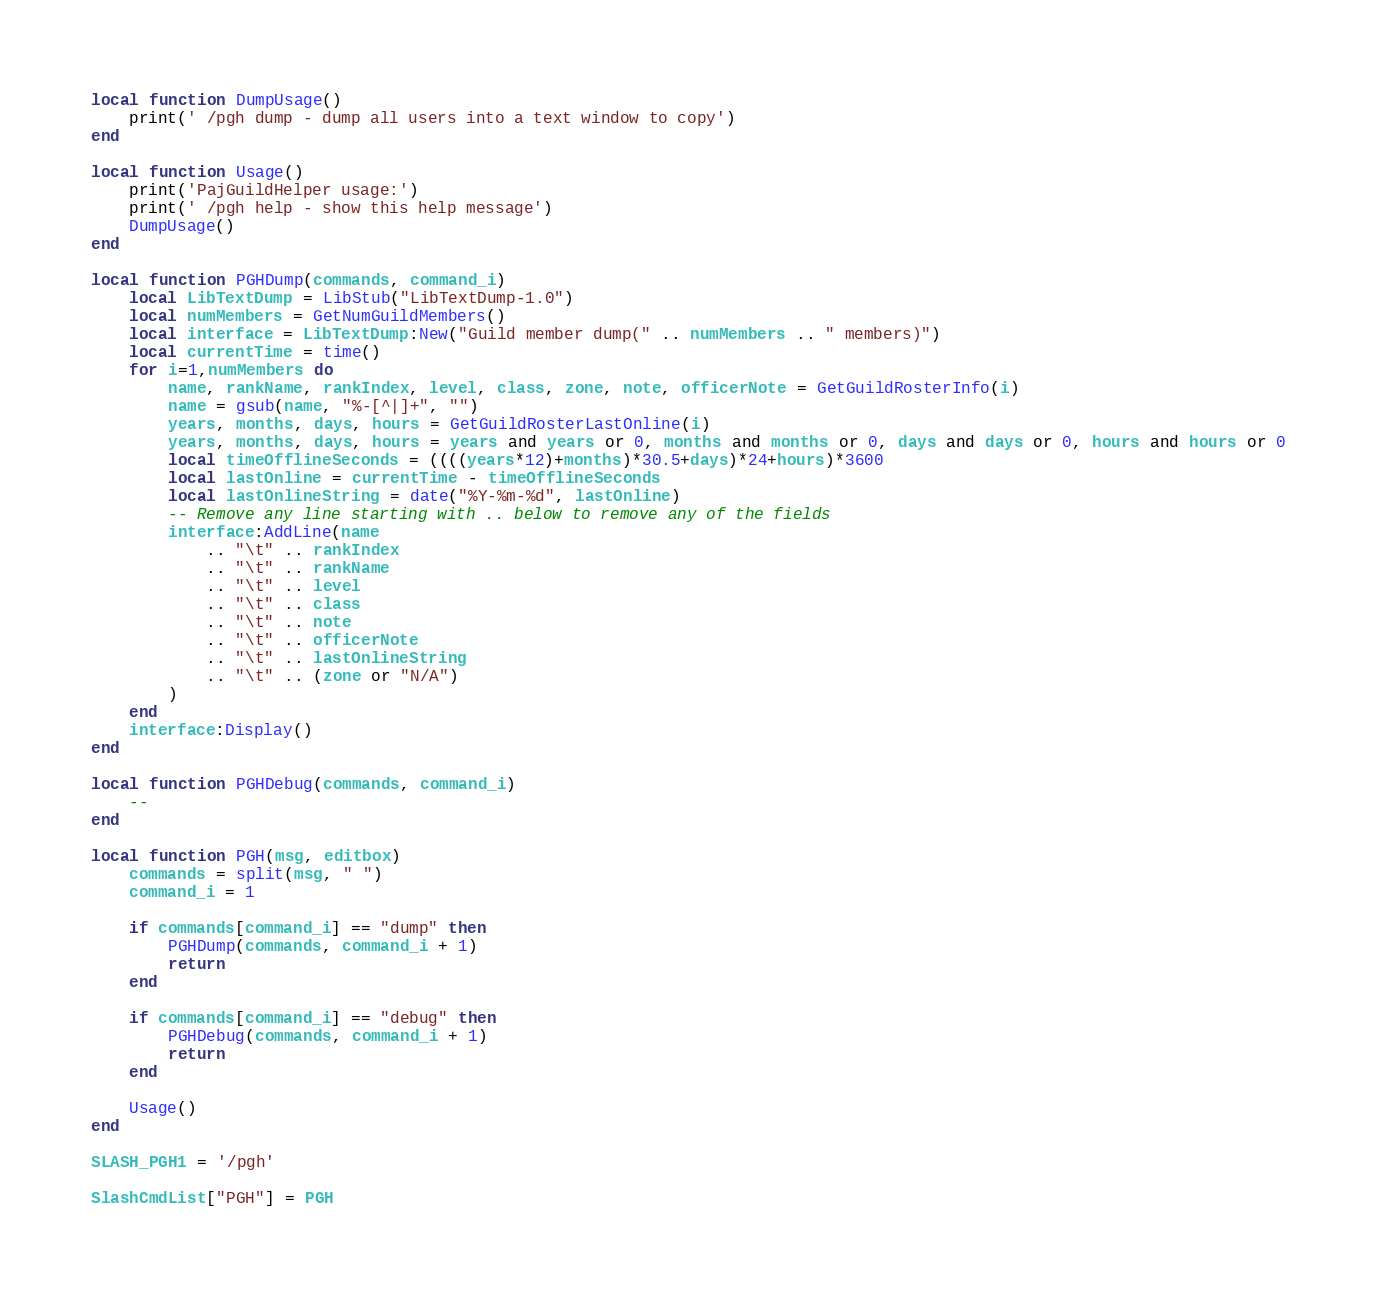Convert code to text. <code><loc_0><loc_0><loc_500><loc_500><_Lua_>local function DumpUsage()
    print(' /pgh dump - dump all users into a text window to copy')
end

local function Usage()
    print('PajGuildHelper usage:')
    print(' /pgh help - show this help message')
    DumpUsage()
end

local function PGHDump(commands, command_i)
    local LibTextDump = LibStub("LibTextDump-1.0")
    local numMembers = GetNumGuildMembers()
    local interface = LibTextDump:New("Guild member dump(" .. numMembers .. " members)")
    local currentTime = time()
    for i=1,numMembers do
        name, rankName, rankIndex, level, class, zone, note, officerNote = GetGuildRosterInfo(i)
        name = gsub(name, "%-[^|]+", "")
        years, months, days, hours = GetGuildRosterLastOnline(i)
        years, months, days, hours = years and years or 0, months and months or 0, days and days or 0, hours and hours or 0
        local timeOfflineSeconds = ((((years*12)+months)*30.5+days)*24+hours)*3600
        local lastOnline = currentTime - timeOfflineSeconds
        local lastOnlineString = date("%Y-%m-%d", lastOnline)
        -- Remove any line starting with .. below to remove any of the fields
        interface:AddLine(name
            .. "\t" .. rankIndex
            .. "\t" .. rankName
            .. "\t" .. level
            .. "\t" .. class
            .. "\t" .. note
            .. "\t" .. officerNote
            .. "\t" .. lastOnlineString
            .. "\t" .. (zone or "N/A")
        )
    end
    interface:Display()
end

local function PGHDebug(commands, command_i)
    --
end

local function PGH(msg, editbox)
    commands = split(msg, " ")
    command_i = 1

    if commands[command_i] == "dump" then
        PGHDump(commands, command_i + 1)
        return
    end

    if commands[command_i] == "debug" then
        PGHDebug(commands, command_i + 1)
        return
    end

    Usage()
end

SLASH_PGH1 = '/pgh'

SlashCmdList["PGH"] = PGH
</code> 